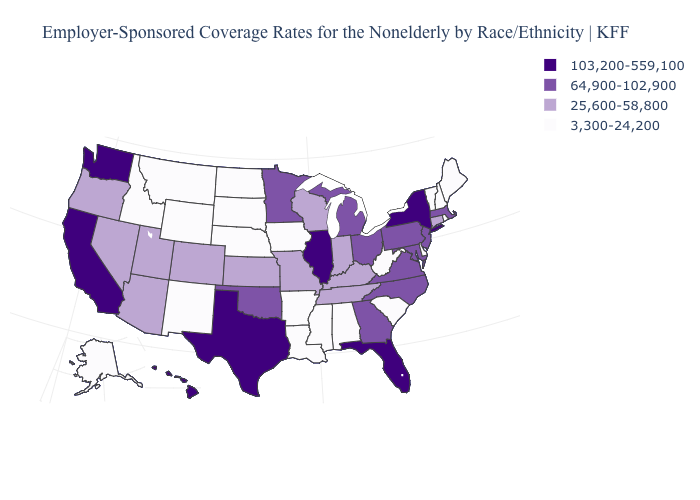What is the value of West Virginia?
Write a very short answer. 3,300-24,200. What is the value of Illinois?
Concise answer only. 103,200-559,100. Does Iowa have the lowest value in the MidWest?
Quick response, please. Yes. What is the highest value in the MidWest ?
Give a very brief answer. 103,200-559,100. Does the map have missing data?
Short answer required. No. Which states hav the highest value in the MidWest?
Short answer required. Illinois. What is the lowest value in states that border Florida?
Concise answer only. 3,300-24,200. Which states have the highest value in the USA?
Be succinct. California, Florida, Hawaii, Illinois, New York, Texas, Washington. Name the states that have a value in the range 25,600-58,800?
Write a very short answer. Arizona, Colorado, Connecticut, Indiana, Kansas, Kentucky, Missouri, Nevada, Oregon, Tennessee, Utah, Wisconsin. What is the highest value in the USA?
Write a very short answer. 103,200-559,100. What is the value of Nebraska?
Keep it brief. 3,300-24,200. Name the states that have a value in the range 3,300-24,200?
Keep it brief. Alabama, Alaska, Arkansas, Delaware, Idaho, Iowa, Louisiana, Maine, Mississippi, Montana, Nebraska, New Hampshire, New Mexico, North Dakota, Rhode Island, South Carolina, South Dakota, Vermont, West Virginia, Wyoming. Does Utah have a higher value than Illinois?
Be succinct. No. How many symbols are there in the legend?
Quick response, please. 4. 